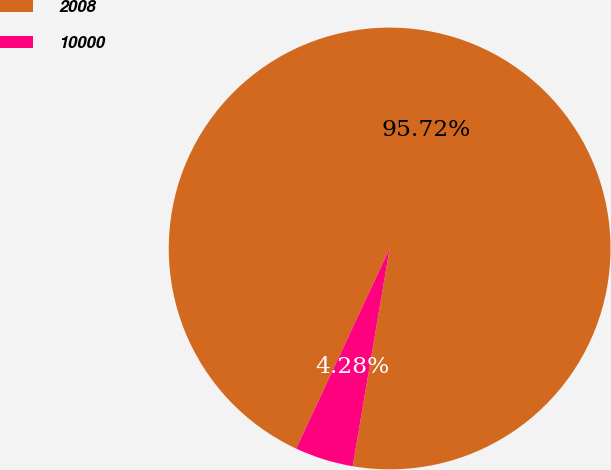<chart> <loc_0><loc_0><loc_500><loc_500><pie_chart><fcel>2008<fcel>10000<nl><fcel>95.72%<fcel>4.28%<nl></chart> 